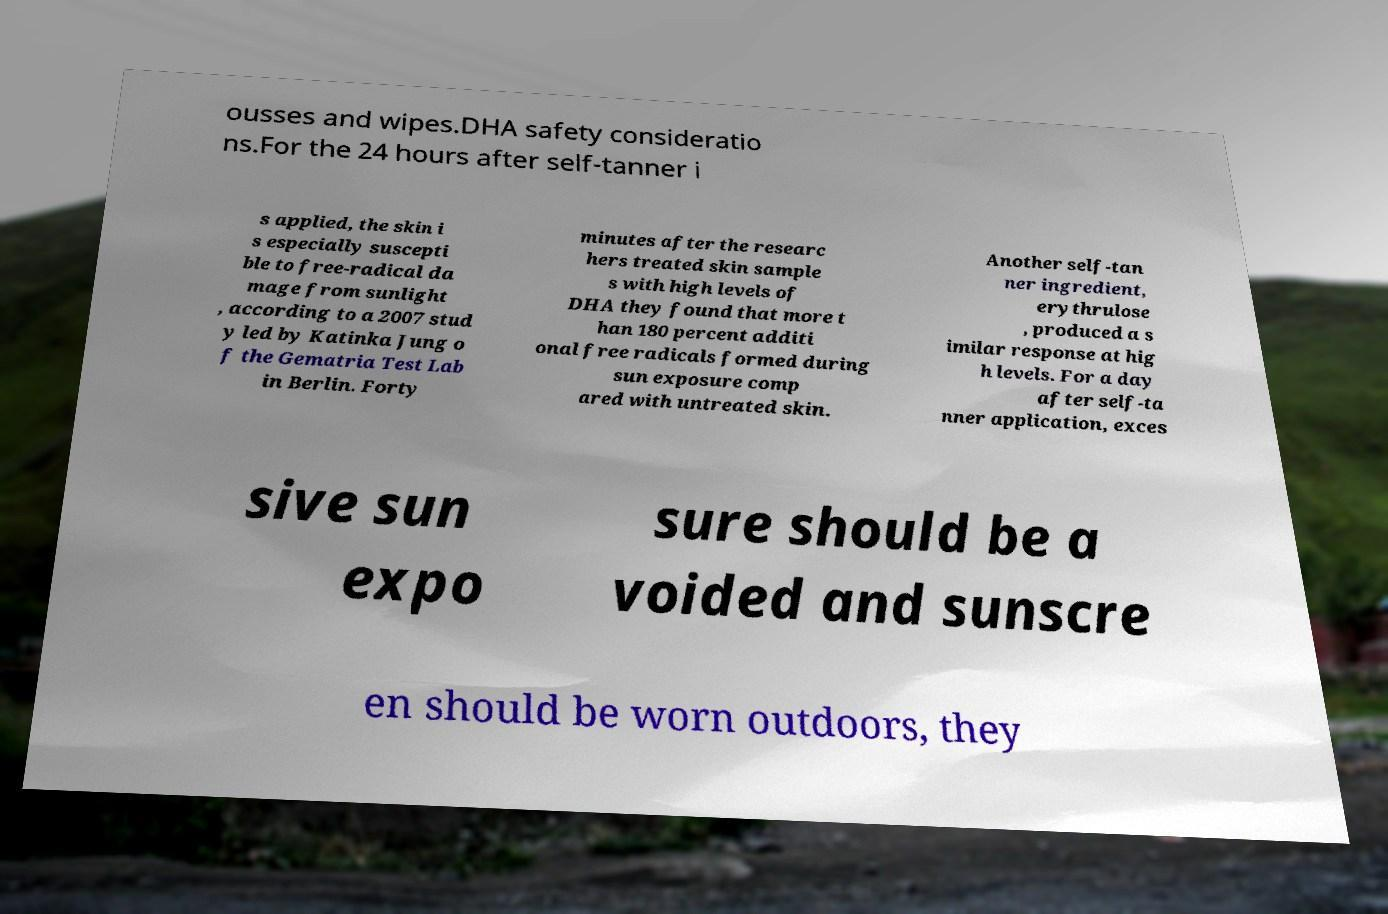Can you accurately transcribe the text from the provided image for me? ousses and wipes.DHA safety consideratio ns.For the 24 hours after self-tanner i s applied, the skin i s especially suscepti ble to free-radical da mage from sunlight , according to a 2007 stud y led by Katinka Jung o f the Gematria Test Lab in Berlin. Forty minutes after the researc hers treated skin sample s with high levels of DHA they found that more t han 180 percent additi onal free radicals formed during sun exposure comp ared with untreated skin. Another self-tan ner ingredient, erythrulose , produced a s imilar response at hig h levels. For a day after self-ta nner application, exces sive sun expo sure should be a voided and sunscre en should be worn outdoors, they 